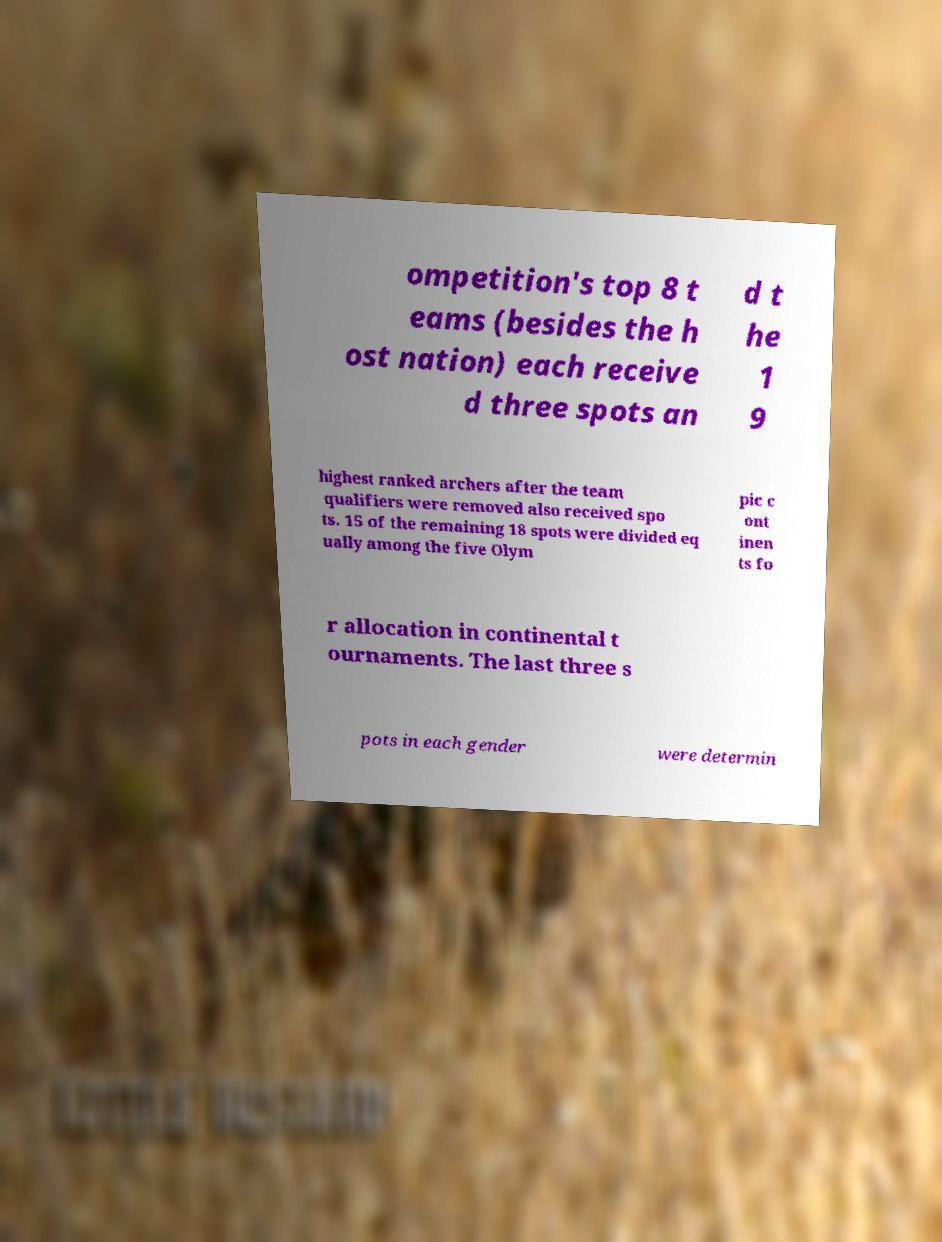Could you extract and type out the text from this image? ompetition's top 8 t eams (besides the h ost nation) each receive d three spots an d t he 1 9 highest ranked archers after the team qualifiers were removed also received spo ts. 15 of the remaining 18 spots were divided eq ually among the five Olym pic c ont inen ts fo r allocation in continental t ournaments. The last three s pots in each gender were determin 